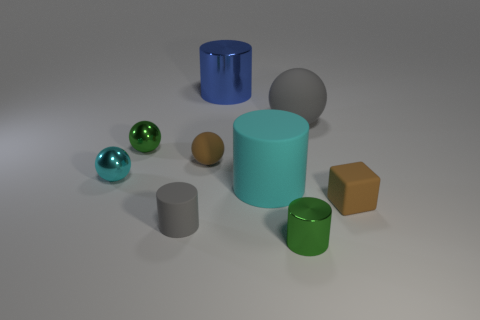Subtract all cubes. How many objects are left? 8 Subtract all big yellow things. Subtract all green spheres. How many objects are left? 8 Add 6 gray matte cylinders. How many gray matte cylinders are left? 7 Add 5 matte things. How many matte things exist? 10 Subtract 0 green blocks. How many objects are left? 9 